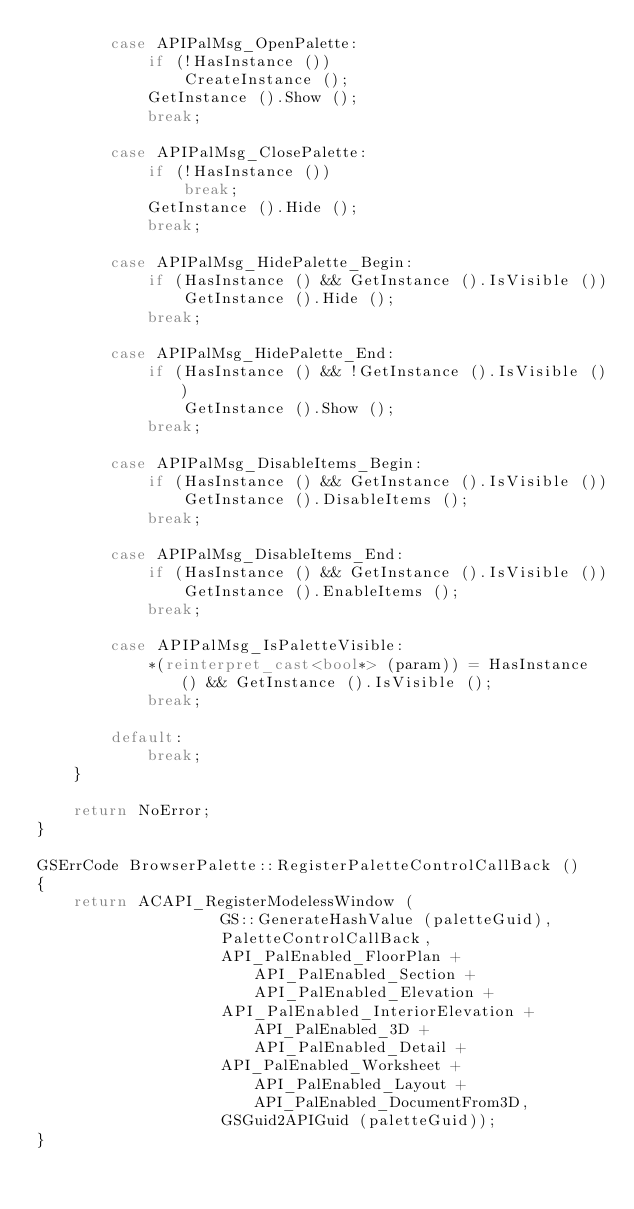<code> <loc_0><loc_0><loc_500><loc_500><_C++_>		case APIPalMsg_OpenPalette:
			if (!HasInstance ())
				CreateInstance ();
			GetInstance ().Show ();
			break;

		case APIPalMsg_ClosePalette:
			if (!HasInstance ())
				break;
			GetInstance ().Hide ();
			break;

		case APIPalMsg_HidePalette_Begin:
			if (HasInstance () && GetInstance ().IsVisible ())
				GetInstance ().Hide ();
			break;

		case APIPalMsg_HidePalette_End:
			if (HasInstance () && !GetInstance ().IsVisible ())
				GetInstance ().Show ();
			break;

		case APIPalMsg_DisableItems_Begin:
			if (HasInstance () && GetInstance ().IsVisible ())
				GetInstance ().DisableItems ();
			break;

		case APIPalMsg_DisableItems_End:
			if (HasInstance () && GetInstance ().IsVisible ())
				GetInstance ().EnableItems ();
			break;

		case APIPalMsg_IsPaletteVisible:
			*(reinterpret_cast<bool*> (param)) = HasInstance () && GetInstance ().IsVisible ();
			break;

		default:
			break;
	}

	return NoError;
}

GSErrCode BrowserPalette::RegisterPaletteControlCallBack ()
{
	return ACAPI_RegisterModelessWindow (
					GS::GenerateHashValue (paletteGuid),
					PaletteControlCallBack,
					API_PalEnabled_FloorPlan + API_PalEnabled_Section + API_PalEnabled_Elevation +
					API_PalEnabled_InteriorElevation + API_PalEnabled_3D + API_PalEnabled_Detail +
					API_PalEnabled_Worksheet + API_PalEnabled_Layout + API_PalEnabled_DocumentFrom3D,
					GSGuid2APIGuid (paletteGuid));
}
</code> 